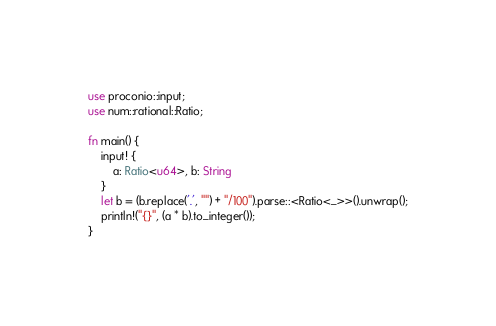Convert code to text. <code><loc_0><loc_0><loc_500><loc_500><_Rust_>use proconio::input;
use num::rational::Ratio;

fn main() {
    input! {
        a: Ratio<u64>, b: String
    }
    let b = (b.replace('.', "") + "/100").parse::<Ratio<_>>().unwrap();
    println!("{}", (a * b).to_integer());
}
</code> 